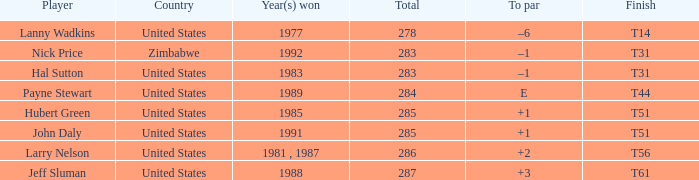Parse the full table. {'header': ['Player', 'Country', 'Year(s) won', 'Total', 'To par', 'Finish'], 'rows': [['Lanny Wadkins', 'United States', '1977', '278', '–6', 'T14'], ['Nick Price', 'Zimbabwe', '1992', '283', '–1', 'T31'], ['Hal Sutton', 'United States', '1983', '283', '–1', 'T31'], ['Payne Stewart', 'United States', '1989', '284', 'E', 'T44'], ['Hubert Green', 'United States', '1985', '285', '+1', 'T51'], ['John Daly', 'United States', '1991', '285', '+1', 'T51'], ['Larry Nelson', 'United States', '1981 , 1987', '286', '+2', 'T56'], ['Jeff Sluman', 'United States', '1988', '287', '+3', 'T61']]} When did nick price win with a "t31" finish? 1992.0. 